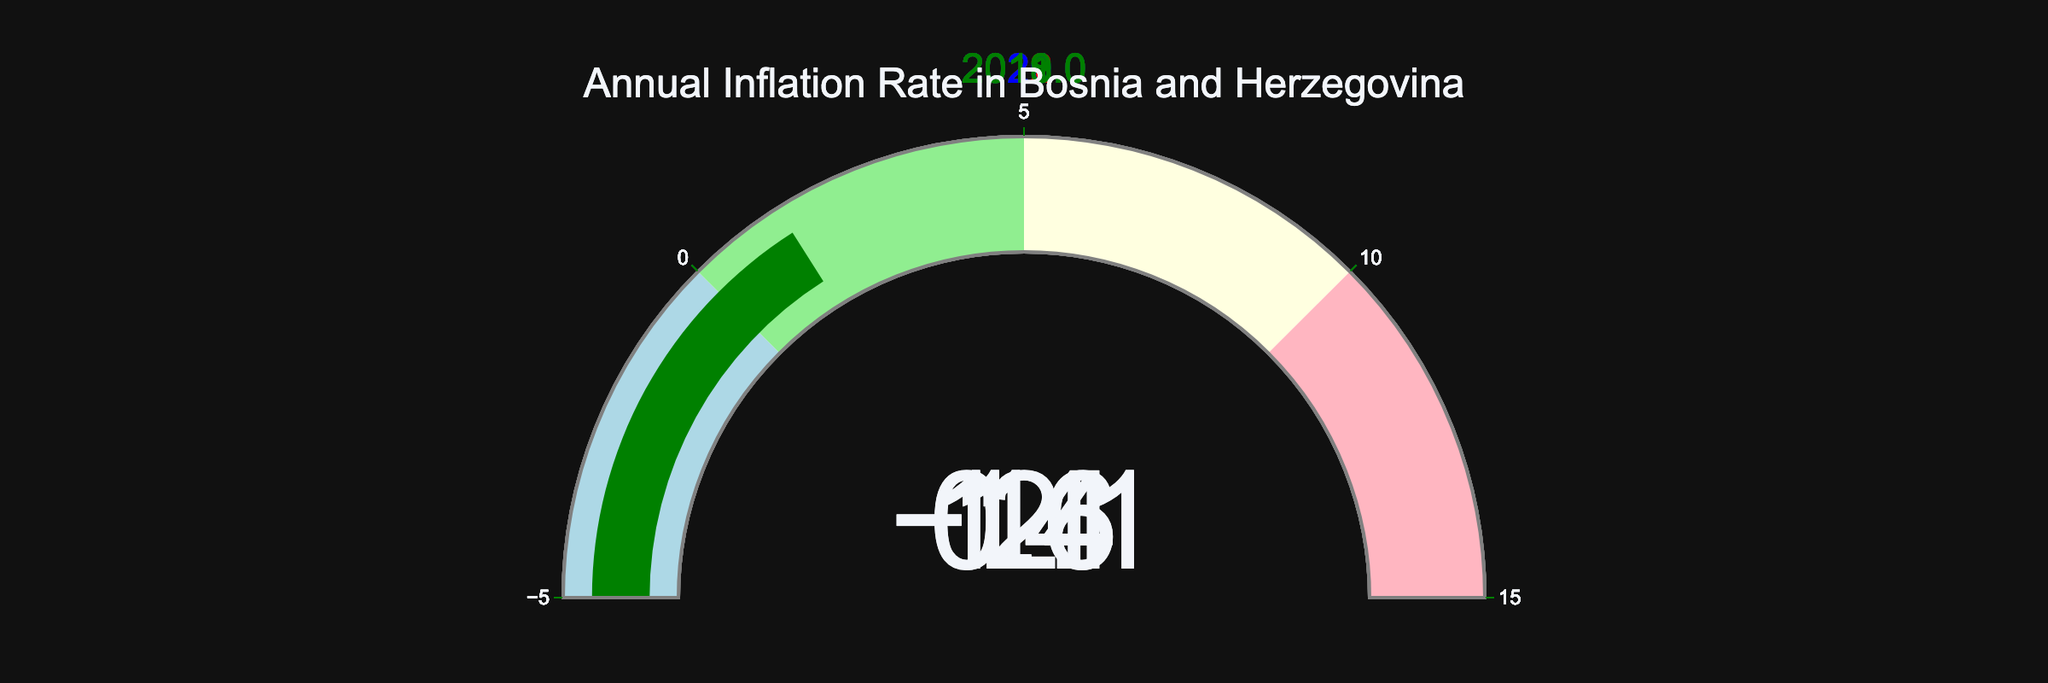How many years are represented in the gauge chart? The gauge chart includes a separate gauge for each year in the dataset. By counting the gauges, we can determine the number of years represented.
Answer: 5 What is the title of the figure? The title of the figure is displayed prominently at the top of the chart.
Answer: "Annual Inflation Rate in Bosnia and Herzegovina" Which year had the highest inflation rate and what was it? By examining the values displayed on each gauge, we can identify the year with the highest inflation rate by finding the largest value.
Answer: 2022, 14.0 In which year was there a deflation, and what was the rate? Deflation is indicated by a negative inflation rate. By looking for the negative value on the gauges, we can identify the year and rate.
Answer: 2020, -1.1 What are the different color schemes used to represent various ranges of inflation rates? The gauge chart uses distinct colors for different ranges. By observing the color steps, we can list them: light blue for negative values, light green for 0-5, light yellow for 5-10, and light pink for 10-15.
Answer: light blue, light green, light yellow, light pink What is the average inflation rate over the years shown? To find the average, sum all the inflation rates and divide by the number of years. Thus, (14.0 + 2.0 + (-1.1) + 0.6 + 1.4) / 5 = 3.38
Answer: 3.38 How many years had positive inflation rates below 5%? By examining the gauges, count the number of years where the rate is positive but less than 5%. These years have rates of 2.0, 0.6, and 1.4.
Answer: 3 How does the inflation rate in 2021 compare to that in 2019? Compare the values on the gauges for the years 2021 and 2019. The rate in 2021 is 2.0, and in 2019 it is 0.6.
Answer: 2021 > 2019 What was the combined inflation rate for 2018 and 2021? Add the rates for 2018 and 2021 together. Thus, 1.4 + 2.0 = 3.4
Answer: 3.4 Which years fall in the highest-colored zone (red), and what does this indicate about their inflation rates? The highest-colored zone (red) represents rates above 10%. Only the year 2022 falls in this zone with a rate of 14.0, indicating very high inflation.
Answer: 2022, very high inflation 